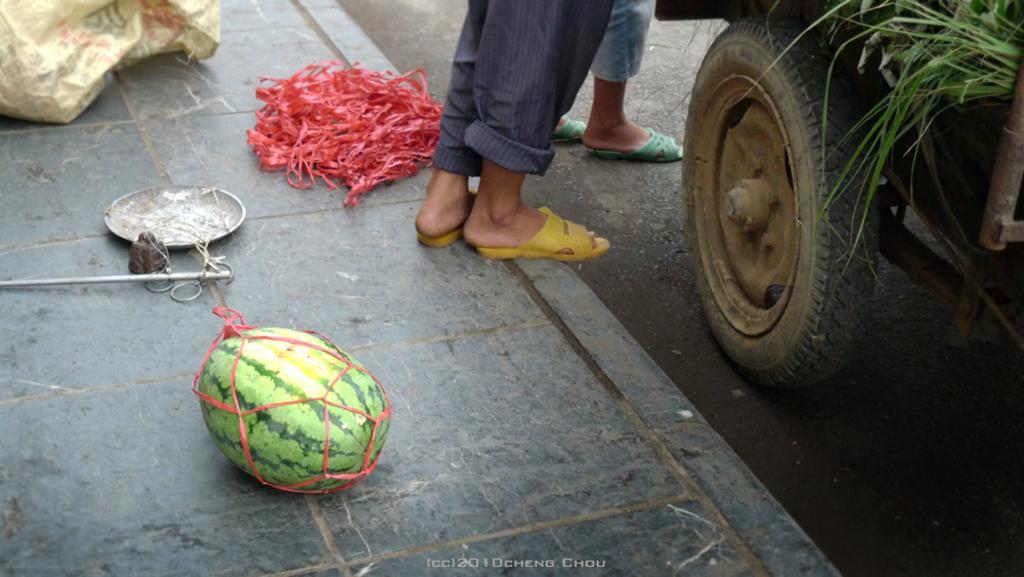How would you summarize this image in a sentence or two? In this image we can see human legs on the ground. In the background we can see motor vehicle with grass in it, watermelon, simple balance and a polythene bag. 